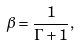<formula> <loc_0><loc_0><loc_500><loc_500>\beta = \frac { 1 } { \Gamma + 1 } ,</formula> 